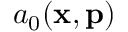Convert formula to latex. <formula><loc_0><loc_0><loc_500><loc_500>a _ { 0 } ( x , p )</formula> 